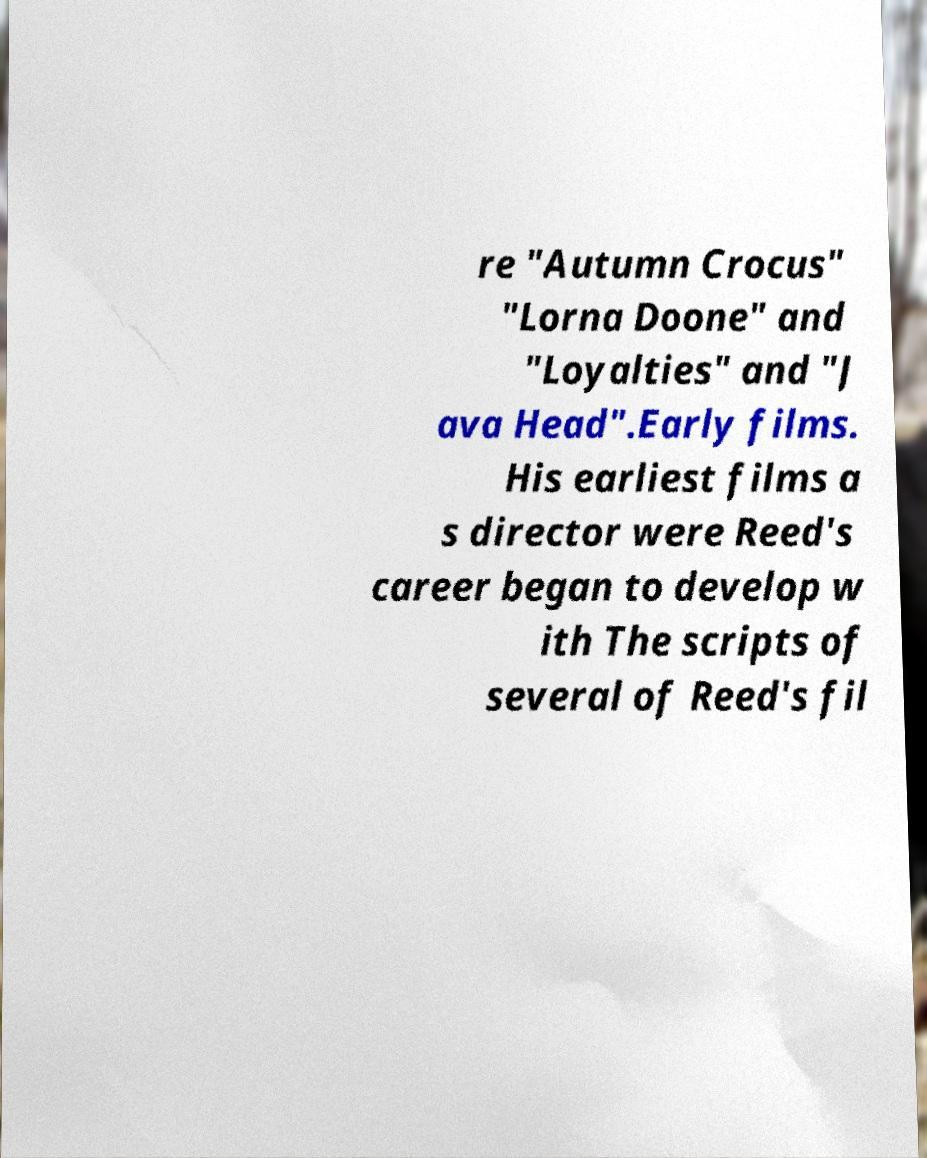Please identify and transcribe the text found in this image. re "Autumn Crocus" "Lorna Doone" and "Loyalties" and "J ava Head".Early films. His earliest films a s director were Reed's career began to develop w ith The scripts of several of Reed's fil 